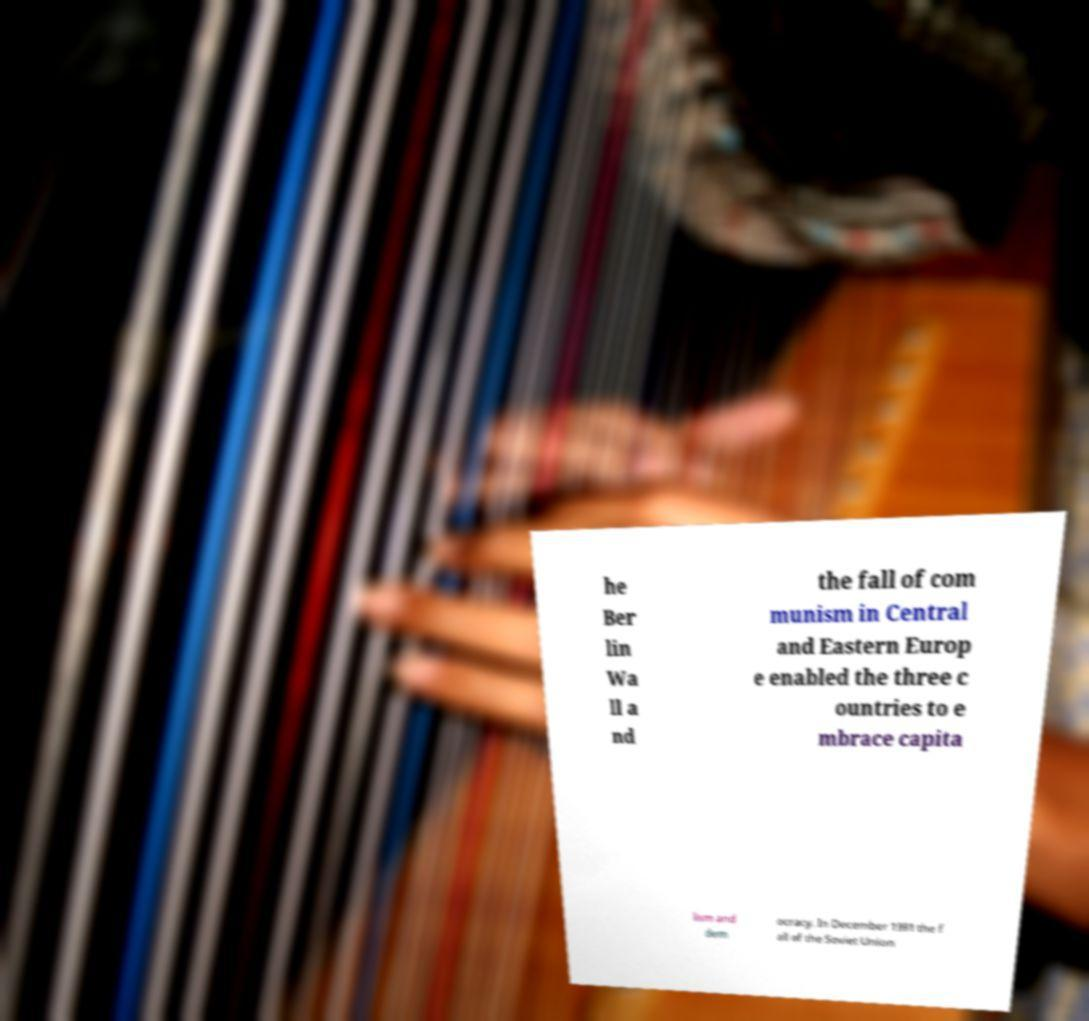There's text embedded in this image that I need extracted. Can you transcribe it verbatim? he Ber lin Wa ll a nd the fall of com munism in Central and Eastern Europ e enabled the three c ountries to e mbrace capita lism and dem ocracy. In December 1991 the f all of the Soviet Union 